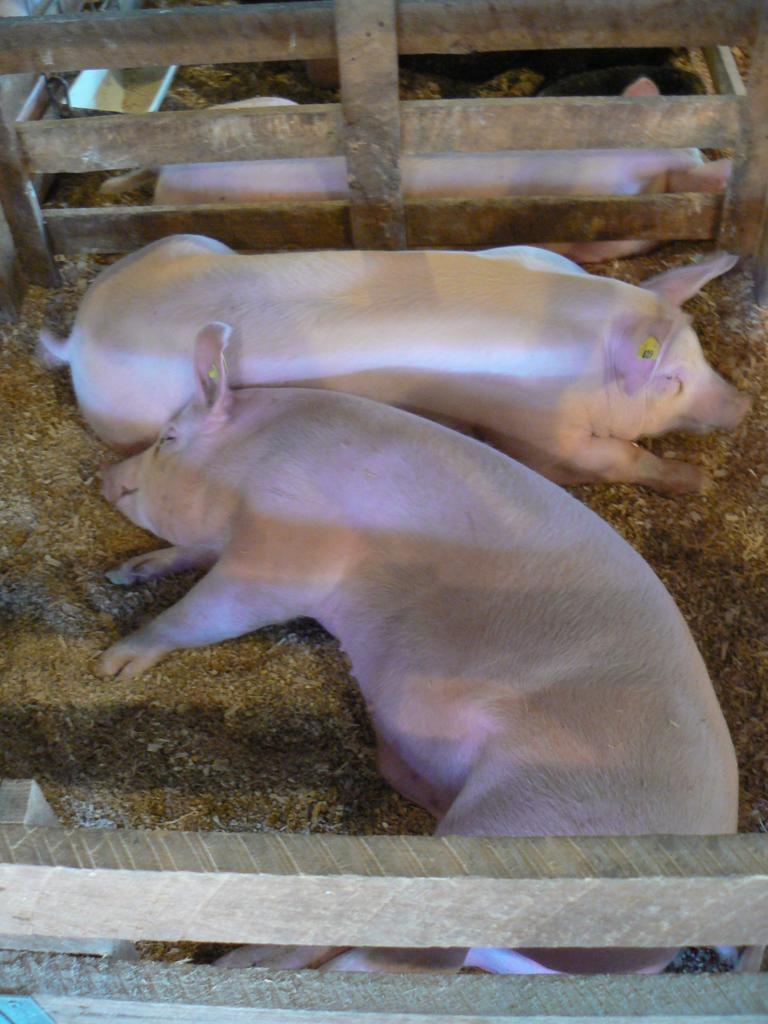What can be seen in the center of the image? There are animals on the ground in the center of the image. What type of barrier is visible in the front of the image? There is a wooden fence in the front of the image. Can you describe the fence in the background of the image? There is a fence in the background of the image. What is the location of the animal in the background? There is an animal behind the fence in the background of the image. Can you see any fish swimming in the water near the animals in the image? There is no water or fish present in the image. Is there a bone visible in the image? There is no bone present in the image. 